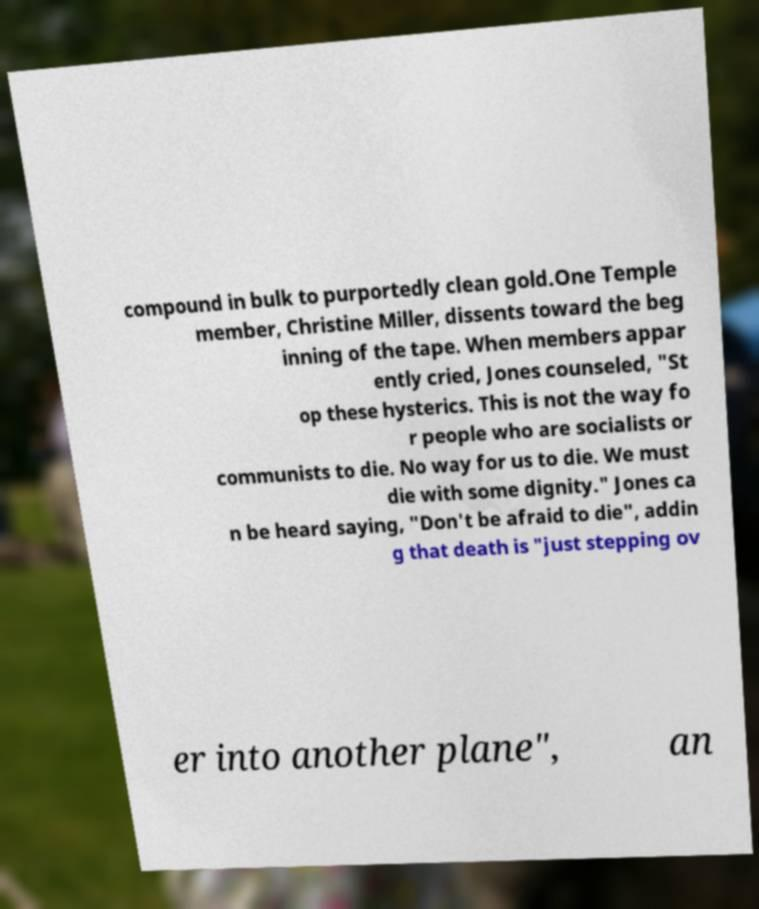Please identify and transcribe the text found in this image. compound in bulk to purportedly clean gold.One Temple member, Christine Miller, dissents toward the beg inning of the tape. When members appar ently cried, Jones counseled, "St op these hysterics. This is not the way fo r people who are socialists or communists to die. No way for us to die. We must die with some dignity." Jones ca n be heard saying, "Don't be afraid to die", addin g that death is "just stepping ov er into another plane", an 